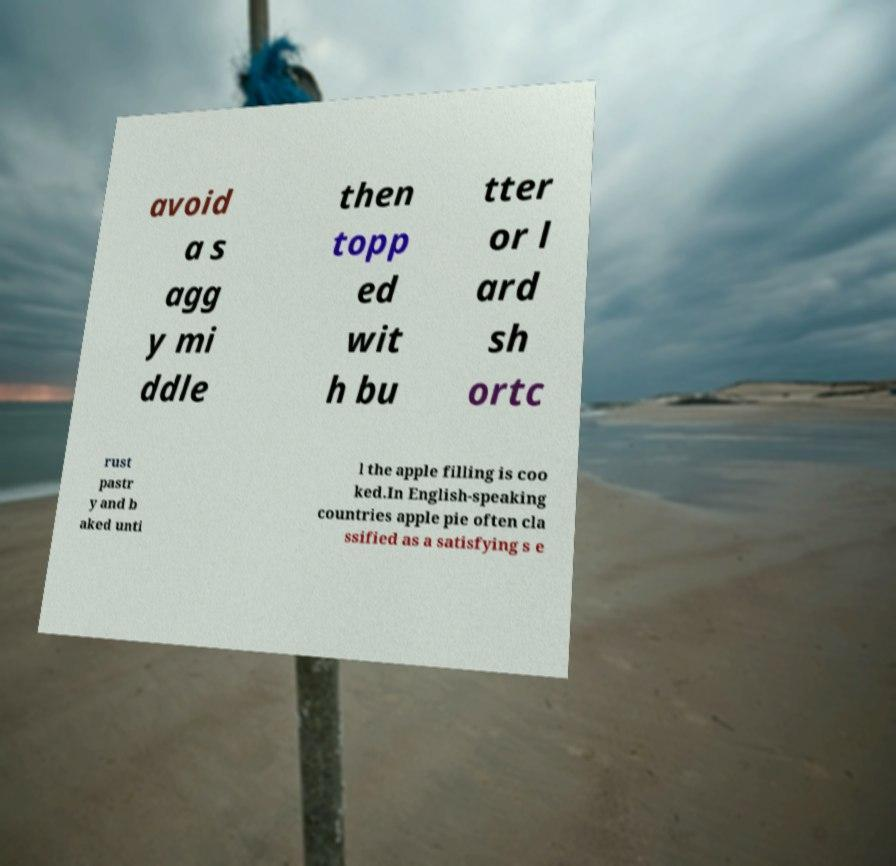Could you assist in decoding the text presented in this image and type it out clearly? avoid a s agg y mi ddle then topp ed wit h bu tter or l ard sh ortc rust pastr y and b aked unti l the apple filling is coo ked.In English-speaking countries apple pie often cla ssified as a satisfying s e 